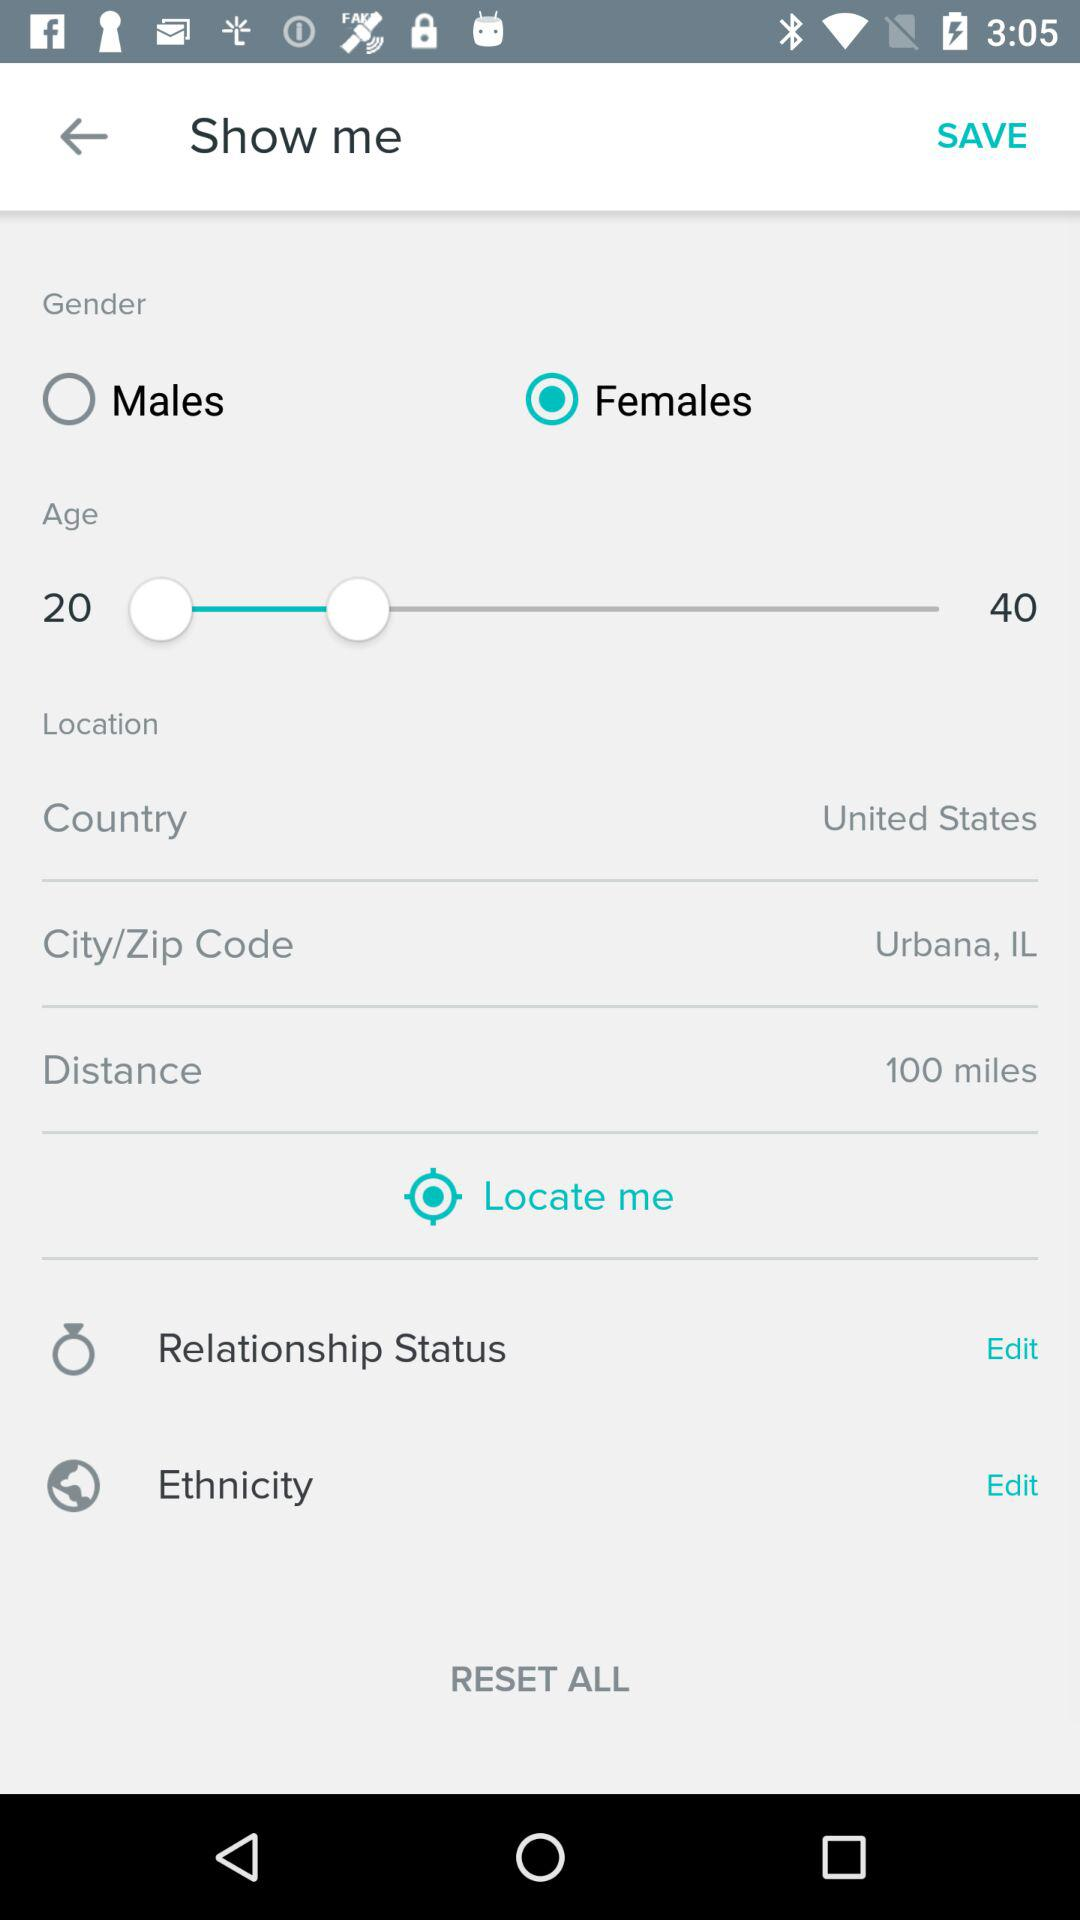What's the selected gender? The selected gender is "Females". 